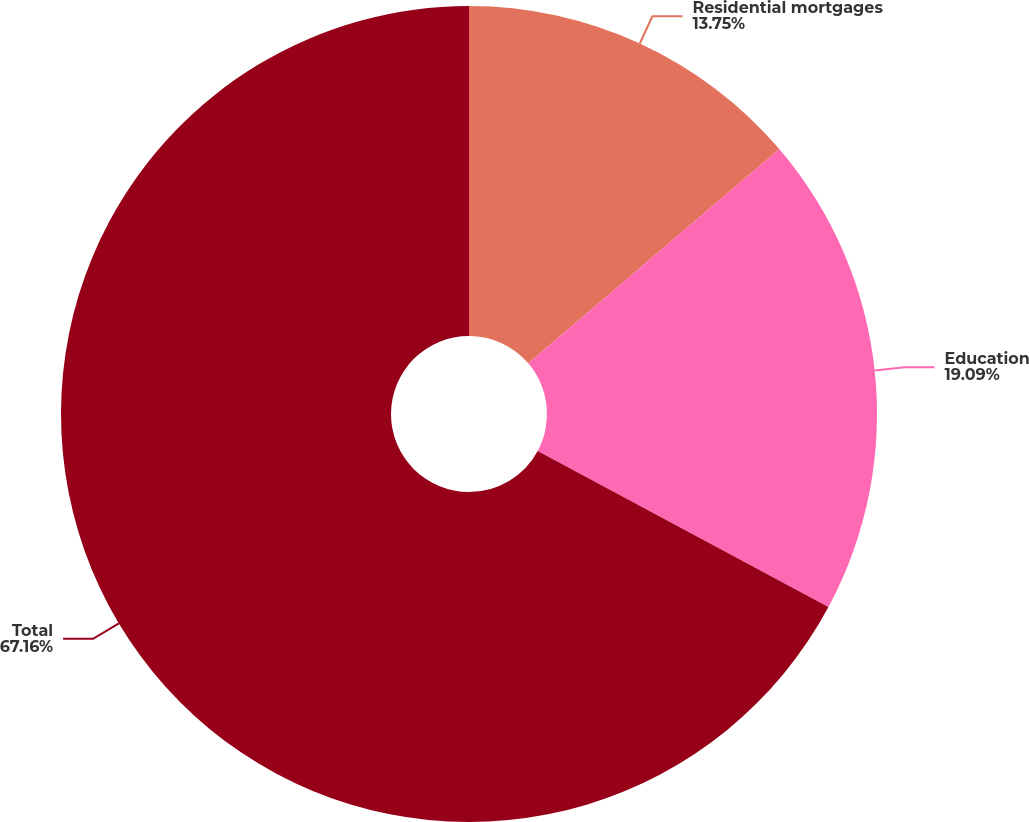Convert chart to OTSL. <chart><loc_0><loc_0><loc_500><loc_500><pie_chart><fcel>Residential mortgages<fcel>Education<fcel>Total<nl><fcel>13.75%<fcel>19.09%<fcel>67.15%<nl></chart> 